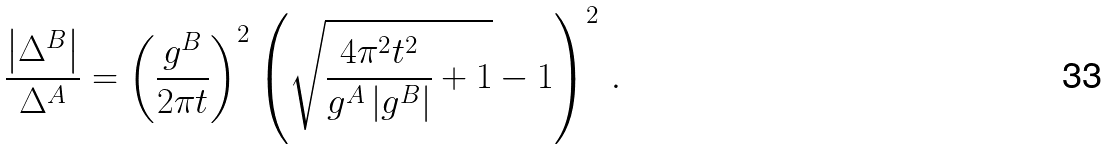<formula> <loc_0><loc_0><loc_500><loc_500>\frac { \left | \Delta ^ { B } \right | } { \Delta ^ { A } } = \left ( \frac { g ^ { B } } { 2 \pi t } \right ) ^ { 2 } \left ( \sqrt { \frac { 4 \pi ^ { 2 } t ^ { 2 } } { g ^ { A } \left | g ^ { B } \right | } + 1 } - 1 \right ) ^ { 2 } \, .</formula> 